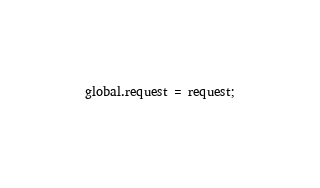<code> <loc_0><loc_0><loc_500><loc_500><_JavaScript_>
global.request = request;
</code> 